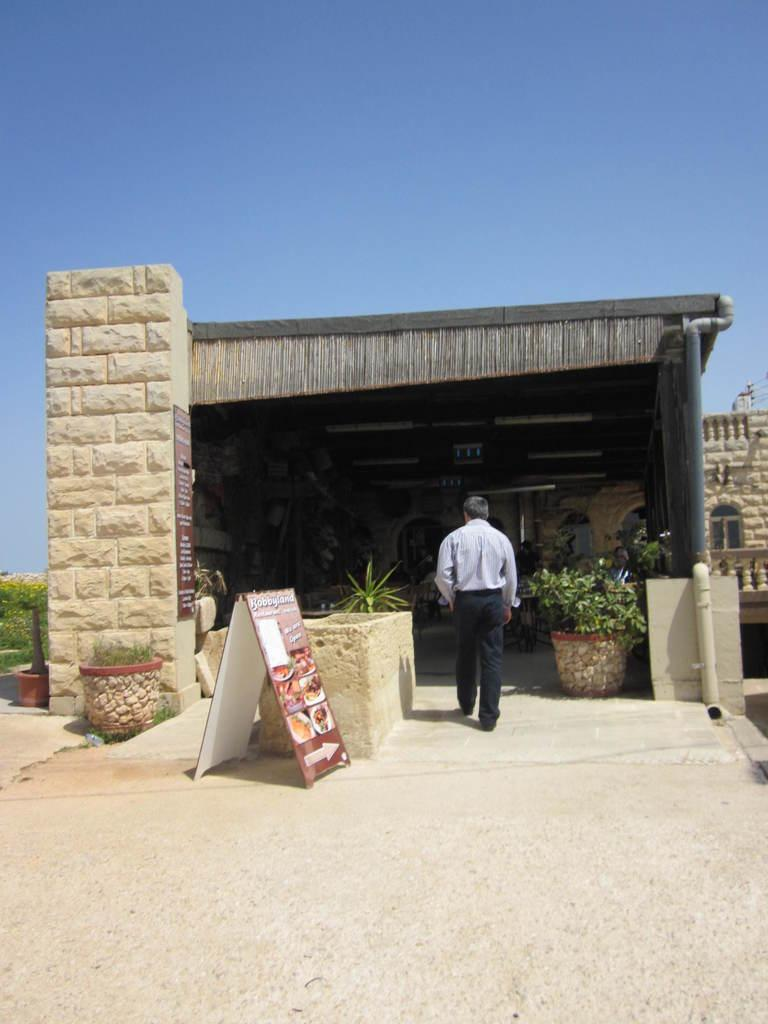Who is in the image? There is a man in the image. What is the man doing in the image? The man is walking into a house. What can be seen beside the man? There are plants and a board beside the man. What is on the right side of the image? There is a pipe on the right side of the image. What type of camera can be seen on the coast in the image? There is no camera or coast present in the image; it features a man walking into a house with plants, a board, and a pipe nearby. 